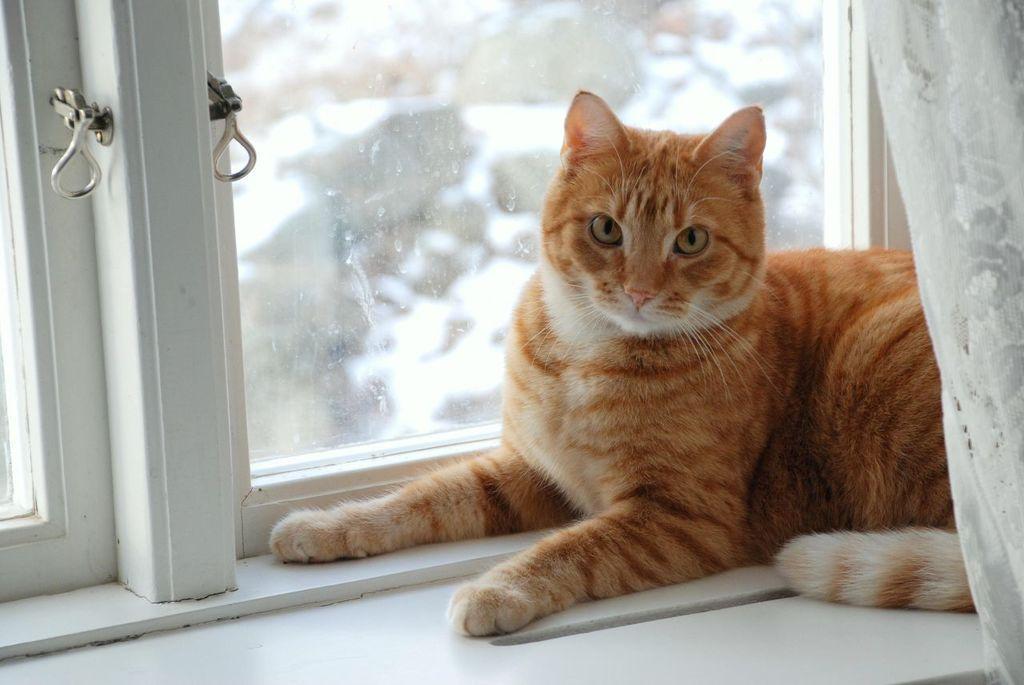Please provide a concise description of this image. As we can see in the image there are windows, white color curtain and cat. 